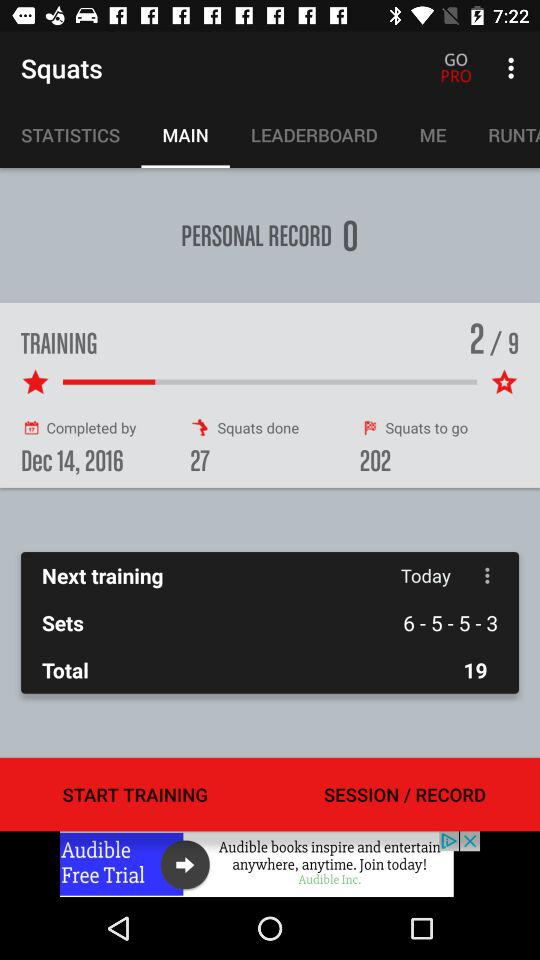How many squats have been done? There were a total of 27 squats performed. 